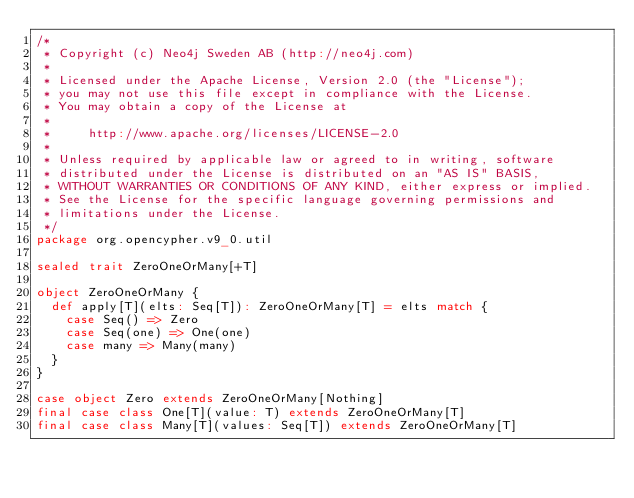<code> <loc_0><loc_0><loc_500><loc_500><_Scala_>/*
 * Copyright (c) Neo4j Sweden AB (http://neo4j.com)
 *
 * Licensed under the Apache License, Version 2.0 (the "License");
 * you may not use this file except in compliance with the License.
 * You may obtain a copy of the License at
 *
 *     http://www.apache.org/licenses/LICENSE-2.0
 *
 * Unless required by applicable law or agreed to in writing, software
 * distributed under the License is distributed on an "AS IS" BASIS,
 * WITHOUT WARRANTIES OR CONDITIONS OF ANY KIND, either express or implied.
 * See the License for the specific language governing permissions and
 * limitations under the License.
 */
package org.opencypher.v9_0.util

sealed trait ZeroOneOrMany[+T]

object ZeroOneOrMany {
  def apply[T](elts: Seq[T]): ZeroOneOrMany[T] = elts match {
    case Seq() => Zero
    case Seq(one) => One(one)
    case many => Many(many)
  }
}

case object Zero extends ZeroOneOrMany[Nothing]
final case class One[T](value: T) extends ZeroOneOrMany[T]
final case class Many[T](values: Seq[T]) extends ZeroOneOrMany[T]
</code> 